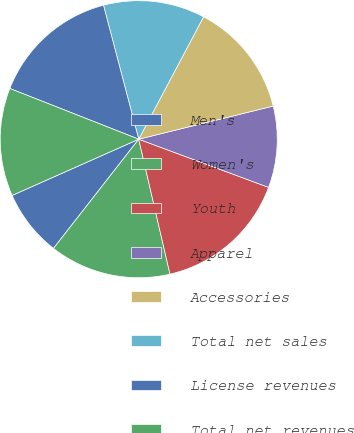<chart> <loc_0><loc_0><loc_500><loc_500><pie_chart><fcel>Men's<fcel>Women's<fcel>Youth<fcel>Apparel<fcel>Accessories<fcel>Total net sales<fcel>License revenues<fcel>Total net revenues<nl><fcel>7.8%<fcel>14.17%<fcel>15.72%<fcel>9.5%<fcel>13.4%<fcel>11.85%<fcel>14.94%<fcel>12.62%<nl></chart> 